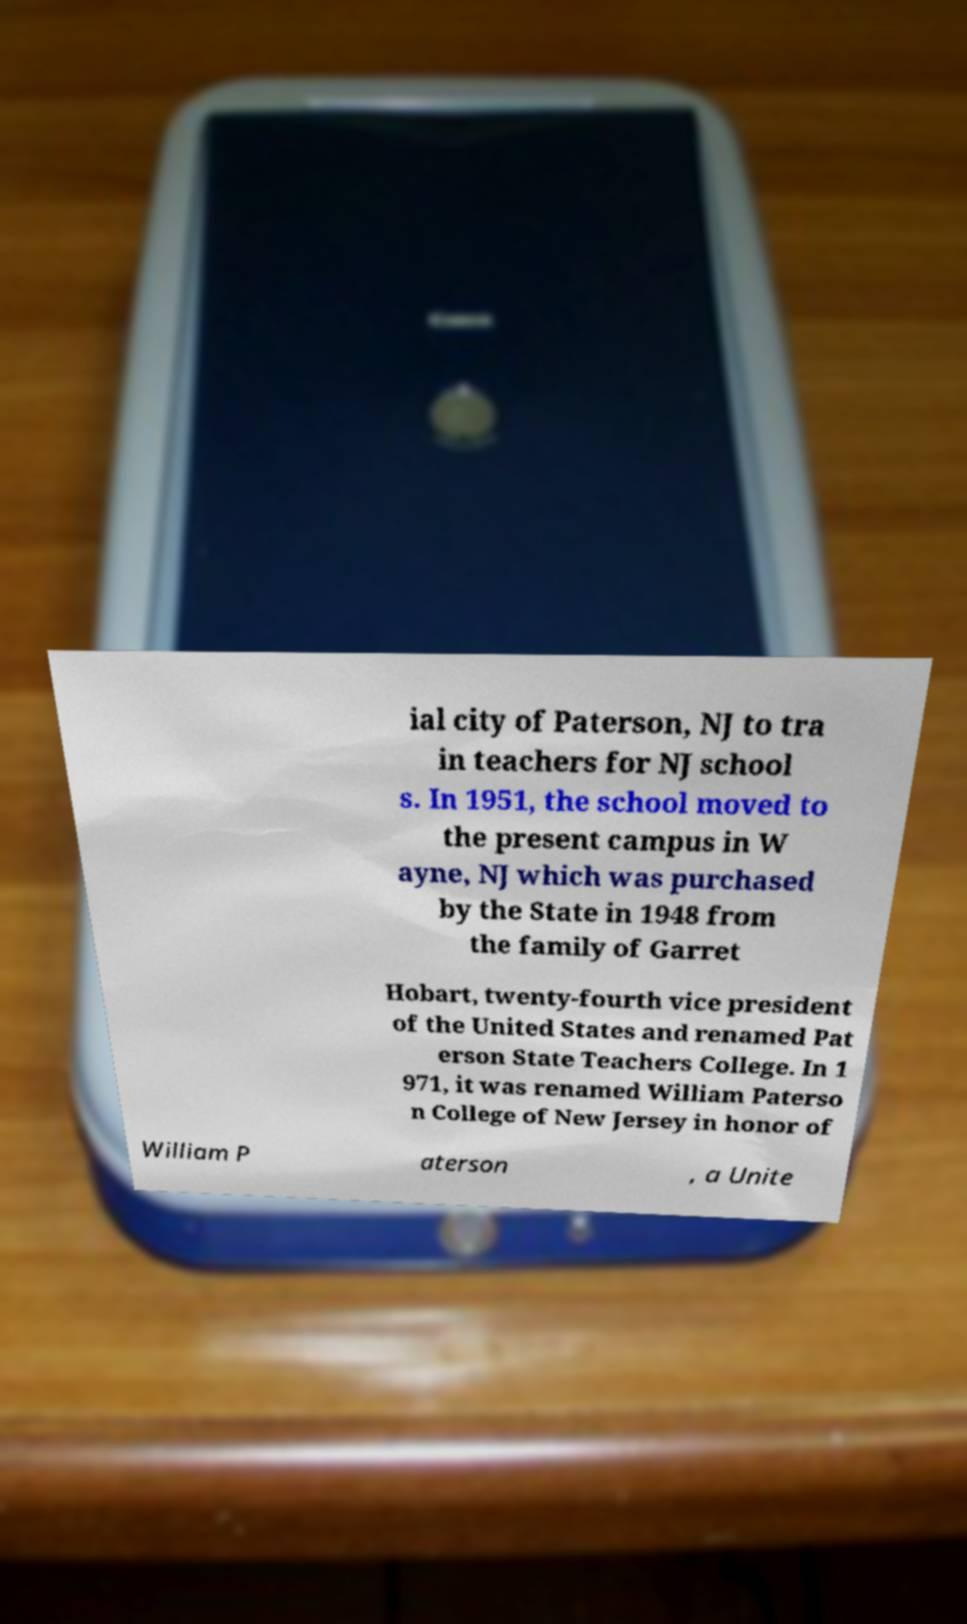For documentation purposes, I need the text within this image transcribed. Could you provide that? ial city of Paterson, NJ to tra in teachers for NJ school s. In 1951, the school moved to the present campus in W ayne, NJ which was purchased by the State in 1948 from the family of Garret Hobart, twenty-fourth vice president of the United States and renamed Pat erson State Teachers College. In 1 971, it was renamed William Paterso n College of New Jersey in honor of William P aterson , a Unite 